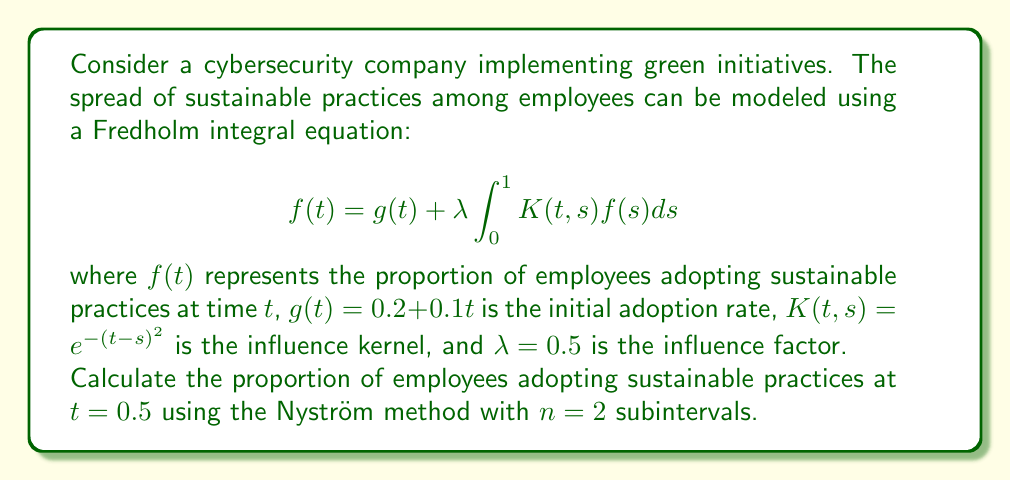What is the answer to this math problem? To solve this problem using the Nyström method, we follow these steps:

1) Divide the interval [0, 1] into n = 2 subintervals. The nodes are:
   $t_1 = 0.25$ and $t_2 = 0.75$

2) Set up the system of linear equations:
   $$f(t_i) = g(t_i) + \lambda \sum_{j=1}^n w_j K(t_i, t_j) f(t_j)$$
   where $w_j = \frac{1}{n} = 0.5$ are the weights for the trapezoidal rule.

3) Substitute the values:
   $$f(0.25) = 0.225 + 0.5 \cdot 0.5 [e^{-(0.25-0.25)^2}f(0.25) + e^{-(0.25-0.75)^2}f(0.75)]$$
   $$f(0.75) = 0.275 + 0.5 \cdot 0.5 [e^{-(0.75-0.25)^2}f(0.25) + e^{-(0.75-0.75)^2}f(0.75)]$$

4) Simplify:
   $$f(0.25) = 0.225 + 0.25 [f(0.25) + 0.7788f(0.75)]$$
   $$f(0.75) = 0.275 + 0.25 [0.7788f(0.25) + f(0.75)]$$

5) Solve the system of equations:
   $$0.75f(0.25) - 0.1947f(0.75) = 0.225$$
   $$-0.1947f(0.25) + 0.75f(0.75) = 0.275$$

   The solution is: $f(0.25) \approx 0.3390$ and $f(0.75) \approx 0.4151$

6) To find $f(0.5)$, we use the original integral equation:
   $$f(0.5) = 0.25 + 0.5 \cdot 0.5 [e^{-(0.5-0.25)^2}f(0.25) + e^{-(0.5-0.75)^2}f(0.75)]$$
   $$f(0.5) = 0.25 + 0.25 [0.9394 \cdot 0.3390 + 0.9394 \cdot 0.4151]$$
   $$f(0.5) \approx 0.3771$$
Answer: $f(0.5) \approx 0.3771$ 